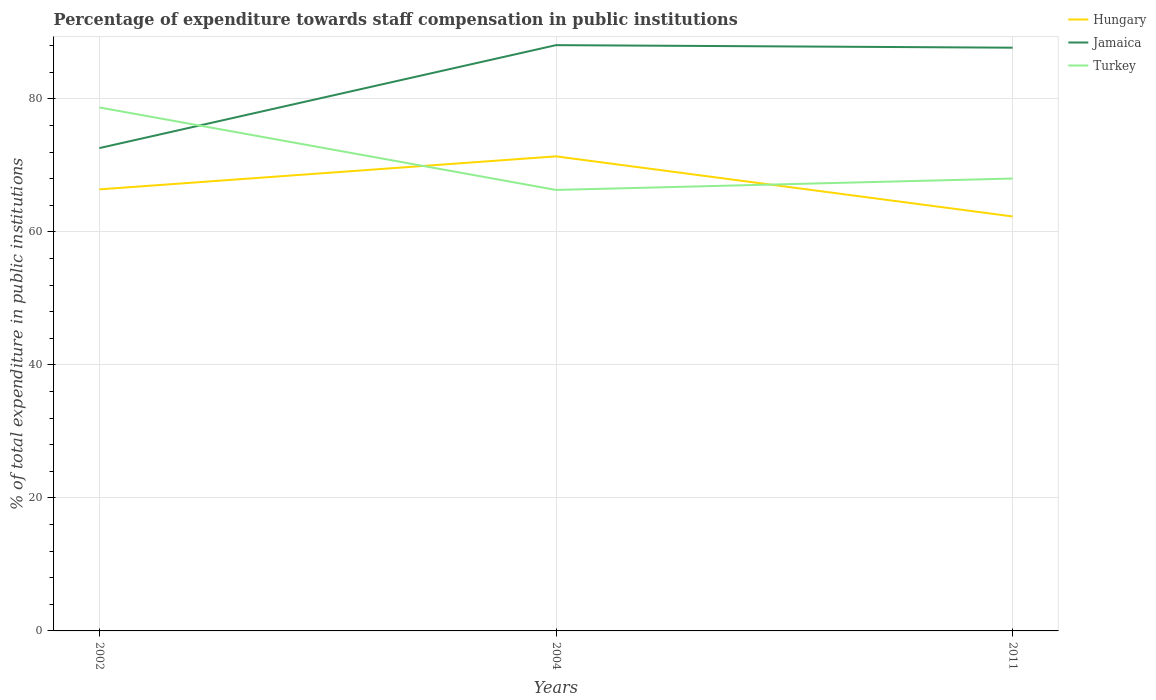Across all years, what is the maximum percentage of expenditure towards staff compensation in Jamaica?
Make the answer very short. 72.6. What is the total percentage of expenditure towards staff compensation in Turkey in the graph?
Provide a succinct answer. 10.69. What is the difference between the highest and the second highest percentage of expenditure towards staff compensation in Jamaica?
Keep it short and to the point. 15.48. What is the difference between the highest and the lowest percentage of expenditure towards staff compensation in Turkey?
Provide a short and direct response. 1. What is the difference between two consecutive major ticks on the Y-axis?
Provide a short and direct response. 20. Does the graph contain any zero values?
Give a very brief answer. No. Does the graph contain grids?
Provide a short and direct response. Yes. What is the title of the graph?
Ensure brevity in your answer.  Percentage of expenditure towards staff compensation in public institutions. Does "Serbia" appear as one of the legend labels in the graph?
Your answer should be very brief. No. What is the label or title of the X-axis?
Make the answer very short. Years. What is the label or title of the Y-axis?
Provide a succinct answer. % of total expenditure in public institutions. What is the % of total expenditure in public institutions of Hungary in 2002?
Provide a succinct answer. 66.39. What is the % of total expenditure in public institutions of Jamaica in 2002?
Keep it short and to the point. 72.6. What is the % of total expenditure in public institutions of Turkey in 2002?
Ensure brevity in your answer.  78.71. What is the % of total expenditure in public institutions of Hungary in 2004?
Give a very brief answer. 71.36. What is the % of total expenditure in public institutions in Jamaica in 2004?
Give a very brief answer. 88.08. What is the % of total expenditure in public institutions in Turkey in 2004?
Make the answer very short. 66.3. What is the % of total expenditure in public institutions in Hungary in 2011?
Offer a terse response. 62.32. What is the % of total expenditure in public institutions in Jamaica in 2011?
Your answer should be compact. 87.69. What is the % of total expenditure in public institutions of Turkey in 2011?
Your answer should be very brief. 68.02. Across all years, what is the maximum % of total expenditure in public institutions in Hungary?
Keep it short and to the point. 71.36. Across all years, what is the maximum % of total expenditure in public institutions in Jamaica?
Provide a short and direct response. 88.08. Across all years, what is the maximum % of total expenditure in public institutions of Turkey?
Your response must be concise. 78.71. Across all years, what is the minimum % of total expenditure in public institutions of Hungary?
Your answer should be very brief. 62.32. Across all years, what is the minimum % of total expenditure in public institutions in Jamaica?
Offer a terse response. 72.6. Across all years, what is the minimum % of total expenditure in public institutions of Turkey?
Your answer should be very brief. 66.3. What is the total % of total expenditure in public institutions in Hungary in the graph?
Provide a succinct answer. 200.06. What is the total % of total expenditure in public institutions of Jamaica in the graph?
Ensure brevity in your answer.  248.37. What is the total % of total expenditure in public institutions of Turkey in the graph?
Offer a very short reply. 213.04. What is the difference between the % of total expenditure in public institutions in Hungary in 2002 and that in 2004?
Give a very brief answer. -4.97. What is the difference between the % of total expenditure in public institutions in Jamaica in 2002 and that in 2004?
Provide a succinct answer. -15.48. What is the difference between the % of total expenditure in public institutions in Turkey in 2002 and that in 2004?
Ensure brevity in your answer.  12.41. What is the difference between the % of total expenditure in public institutions in Hungary in 2002 and that in 2011?
Keep it short and to the point. 4.07. What is the difference between the % of total expenditure in public institutions in Jamaica in 2002 and that in 2011?
Ensure brevity in your answer.  -15.1. What is the difference between the % of total expenditure in public institutions of Turkey in 2002 and that in 2011?
Your answer should be very brief. 10.69. What is the difference between the % of total expenditure in public institutions of Hungary in 2004 and that in 2011?
Make the answer very short. 9.04. What is the difference between the % of total expenditure in public institutions in Jamaica in 2004 and that in 2011?
Your answer should be very brief. 0.38. What is the difference between the % of total expenditure in public institutions of Turkey in 2004 and that in 2011?
Your answer should be compact. -1.72. What is the difference between the % of total expenditure in public institutions of Hungary in 2002 and the % of total expenditure in public institutions of Jamaica in 2004?
Provide a short and direct response. -21.69. What is the difference between the % of total expenditure in public institutions in Hungary in 2002 and the % of total expenditure in public institutions in Turkey in 2004?
Your answer should be very brief. 0.09. What is the difference between the % of total expenditure in public institutions of Jamaica in 2002 and the % of total expenditure in public institutions of Turkey in 2004?
Your answer should be very brief. 6.29. What is the difference between the % of total expenditure in public institutions in Hungary in 2002 and the % of total expenditure in public institutions in Jamaica in 2011?
Your answer should be compact. -21.3. What is the difference between the % of total expenditure in public institutions in Hungary in 2002 and the % of total expenditure in public institutions in Turkey in 2011?
Give a very brief answer. -1.63. What is the difference between the % of total expenditure in public institutions of Jamaica in 2002 and the % of total expenditure in public institutions of Turkey in 2011?
Give a very brief answer. 4.58. What is the difference between the % of total expenditure in public institutions of Hungary in 2004 and the % of total expenditure in public institutions of Jamaica in 2011?
Offer a very short reply. -16.34. What is the difference between the % of total expenditure in public institutions in Hungary in 2004 and the % of total expenditure in public institutions in Turkey in 2011?
Your response must be concise. 3.33. What is the difference between the % of total expenditure in public institutions in Jamaica in 2004 and the % of total expenditure in public institutions in Turkey in 2011?
Make the answer very short. 20.06. What is the average % of total expenditure in public institutions of Hungary per year?
Your response must be concise. 66.69. What is the average % of total expenditure in public institutions of Jamaica per year?
Make the answer very short. 82.79. What is the average % of total expenditure in public institutions in Turkey per year?
Make the answer very short. 71.01. In the year 2002, what is the difference between the % of total expenditure in public institutions of Hungary and % of total expenditure in public institutions of Jamaica?
Give a very brief answer. -6.21. In the year 2002, what is the difference between the % of total expenditure in public institutions of Hungary and % of total expenditure in public institutions of Turkey?
Provide a succinct answer. -12.32. In the year 2002, what is the difference between the % of total expenditure in public institutions of Jamaica and % of total expenditure in public institutions of Turkey?
Provide a short and direct response. -6.11. In the year 2004, what is the difference between the % of total expenditure in public institutions in Hungary and % of total expenditure in public institutions in Jamaica?
Keep it short and to the point. -16.72. In the year 2004, what is the difference between the % of total expenditure in public institutions of Hungary and % of total expenditure in public institutions of Turkey?
Keep it short and to the point. 5.05. In the year 2004, what is the difference between the % of total expenditure in public institutions of Jamaica and % of total expenditure in public institutions of Turkey?
Your response must be concise. 21.77. In the year 2011, what is the difference between the % of total expenditure in public institutions in Hungary and % of total expenditure in public institutions in Jamaica?
Your answer should be compact. -25.38. In the year 2011, what is the difference between the % of total expenditure in public institutions in Hungary and % of total expenditure in public institutions in Turkey?
Keep it short and to the point. -5.7. In the year 2011, what is the difference between the % of total expenditure in public institutions in Jamaica and % of total expenditure in public institutions in Turkey?
Provide a short and direct response. 19.67. What is the ratio of the % of total expenditure in public institutions of Hungary in 2002 to that in 2004?
Offer a very short reply. 0.93. What is the ratio of the % of total expenditure in public institutions in Jamaica in 2002 to that in 2004?
Your answer should be very brief. 0.82. What is the ratio of the % of total expenditure in public institutions of Turkey in 2002 to that in 2004?
Ensure brevity in your answer.  1.19. What is the ratio of the % of total expenditure in public institutions of Hungary in 2002 to that in 2011?
Your answer should be very brief. 1.07. What is the ratio of the % of total expenditure in public institutions in Jamaica in 2002 to that in 2011?
Give a very brief answer. 0.83. What is the ratio of the % of total expenditure in public institutions of Turkey in 2002 to that in 2011?
Provide a short and direct response. 1.16. What is the ratio of the % of total expenditure in public institutions of Hungary in 2004 to that in 2011?
Keep it short and to the point. 1.15. What is the ratio of the % of total expenditure in public institutions in Turkey in 2004 to that in 2011?
Your answer should be compact. 0.97. What is the difference between the highest and the second highest % of total expenditure in public institutions of Hungary?
Provide a short and direct response. 4.97. What is the difference between the highest and the second highest % of total expenditure in public institutions in Jamaica?
Your answer should be very brief. 0.38. What is the difference between the highest and the second highest % of total expenditure in public institutions in Turkey?
Your answer should be compact. 10.69. What is the difference between the highest and the lowest % of total expenditure in public institutions of Hungary?
Provide a short and direct response. 9.04. What is the difference between the highest and the lowest % of total expenditure in public institutions in Jamaica?
Your response must be concise. 15.48. What is the difference between the highest and the lowest % of total expenditure in public institutions in Turkey?
Your answer should be very brief. 12.41. 